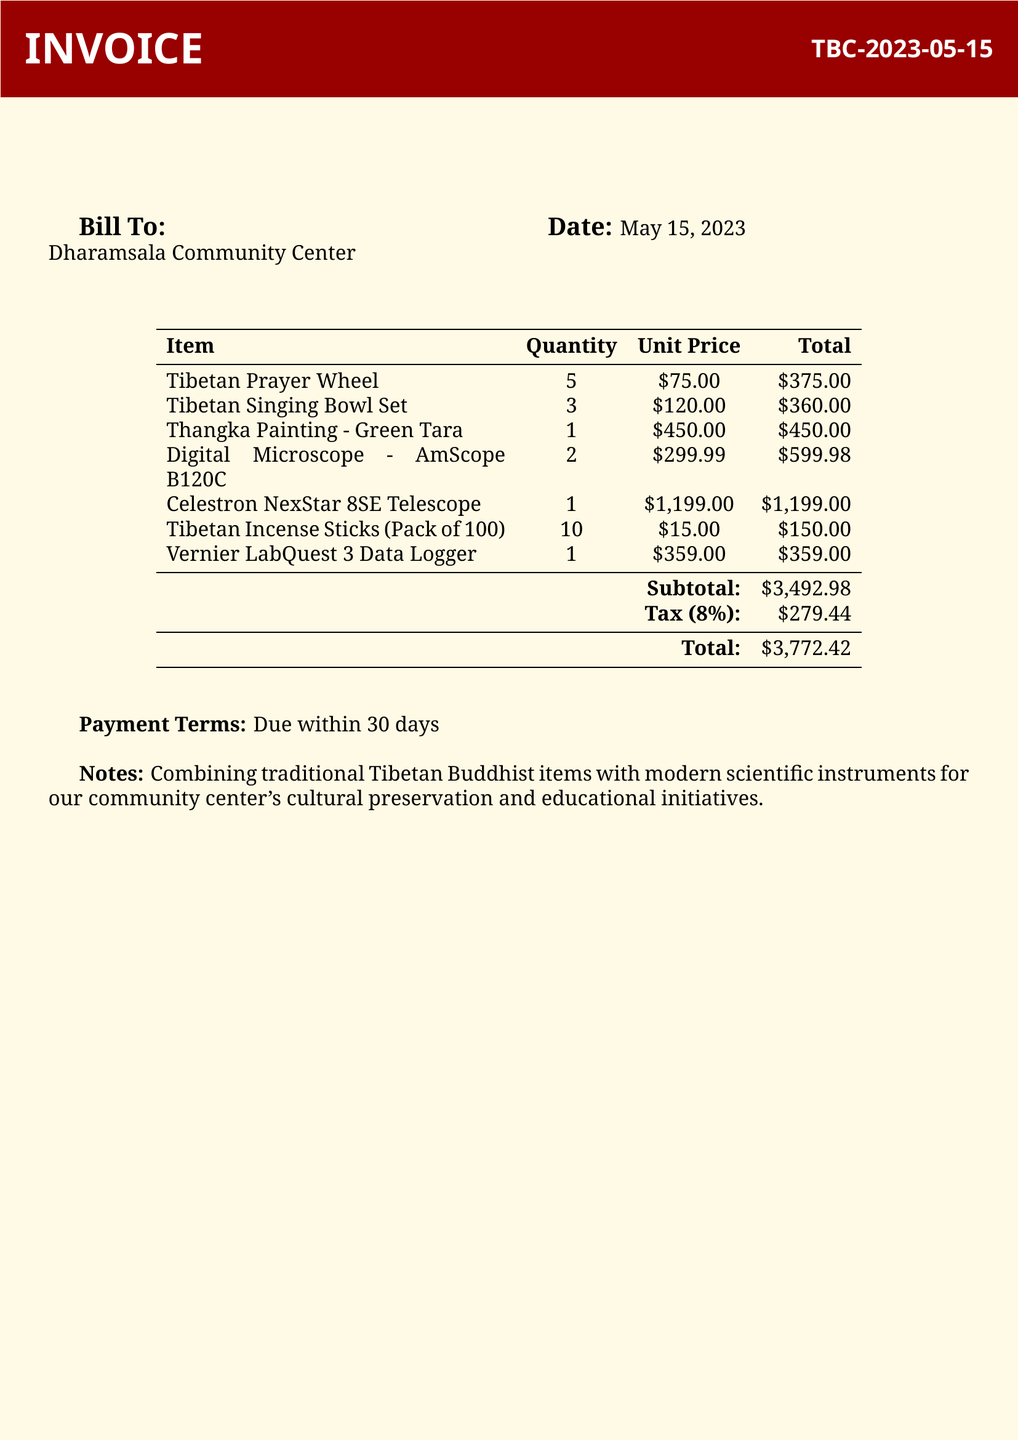What is the invoice number? The invoice number is listed at the top of the document as TBC-2023-05-15.
Answer: TBC-2023-05-15 What is the date of the invoice? The date is indicated clearly in the document as May 15, 2023.
Answer: May 15, 2023 How many Tibetan Incense Sticks were purchased? The quantity of Tibetan Incense Sticks is specified in the invoice as 10.
Answer: 10 What is the total amount due? The total amount due is found at the end of the invoice as $3,772.42.
Answer: $3,772.42 What is the subtotal before tax? The subtotal before tax is noted in the document as $3,492.98.
Answer: $3,492.98 What type of telescope was purchased? The type of telescope mentioned in the invoice is Celestron NexStar 8SE.
Answer: Celestron NexStar 8SE What are the payment terms? The payment terms are outlined in the document as due within 30 days.
Answer: Due within 30 days What is the purpose of combining traditional items with modern instruments? The purpose is described in the notes section as cultural preservation and educational initiatives for the community center.
Answer: Cultural preservation and educational initiatives How many digital microscopes were ordered? The document specifies that 2 digital microscopes were ordered.
Answer: 2 